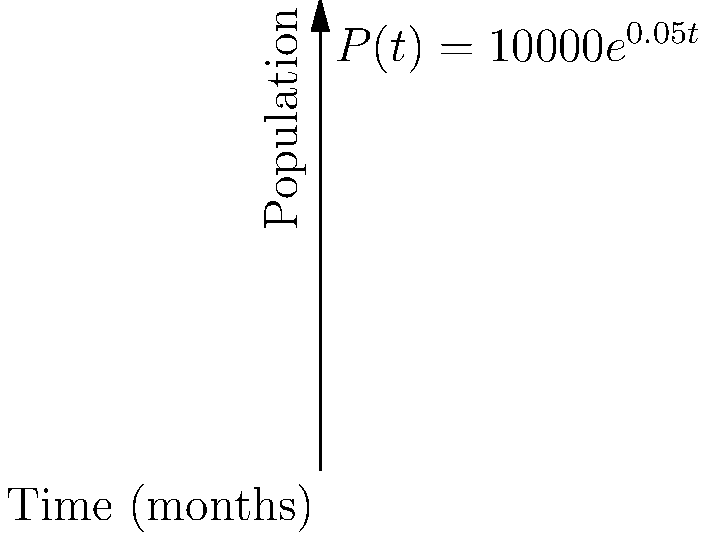A refugee camp's population is growing exponentially, modeled by the function $P(t) = 10000e^{0.05t}$, where $P$ is the population and $t$ is time in months. Calculate the rate of population change after 6 months. To find the rate of population change, we need to differentiate the given function and evaluate it at $t=6$.

1) The given function is $P(t) = 10000e^{0.05t}$

2) Differentiate $P(t)$ with respect to $t$:
   $\frac{dP}{dt} = 10000 \cdot 0.05 \cdot e^{0.05t} = 500e^{0.05t}$

3) This derivative represents the rate of change of the population at any time $t$.

4) To find the rate of change at 6 months, substitute $t=6$:
   $\frac{dP}{dt}\bigg|_{t=6} = 500e^{0.05(6)} = 500e^{0.3}$

5) Calculate this value:
   $500e^{0.3} \approx 674.91$

Therefore, after 6 months, the population is increasing at a rate of approximately 675 people per month.
Answer: 675 people/month 